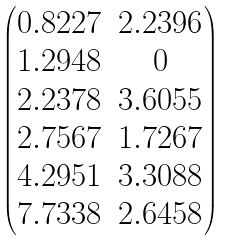<formula> <loc_0><loc_0><loc_500><loc_500>\begin{pmatrix} 0 . 8 2 2 7 & 2 . 2 3 9 6 \\ 1 . 2 9 4 8 & 0 \\ 2 . 2 3 7 8 & 3 . 6 0 5 5 \\ 2 . 7 5 6 7 & 1 . 7 2 6 7 \\ 4 . 2 9 5 1 & 3 . 3 0 8 8 \\ 7 . 7 3 3 8 & 2 . 6 4 5 8 \end{pmatrix}</formula> 